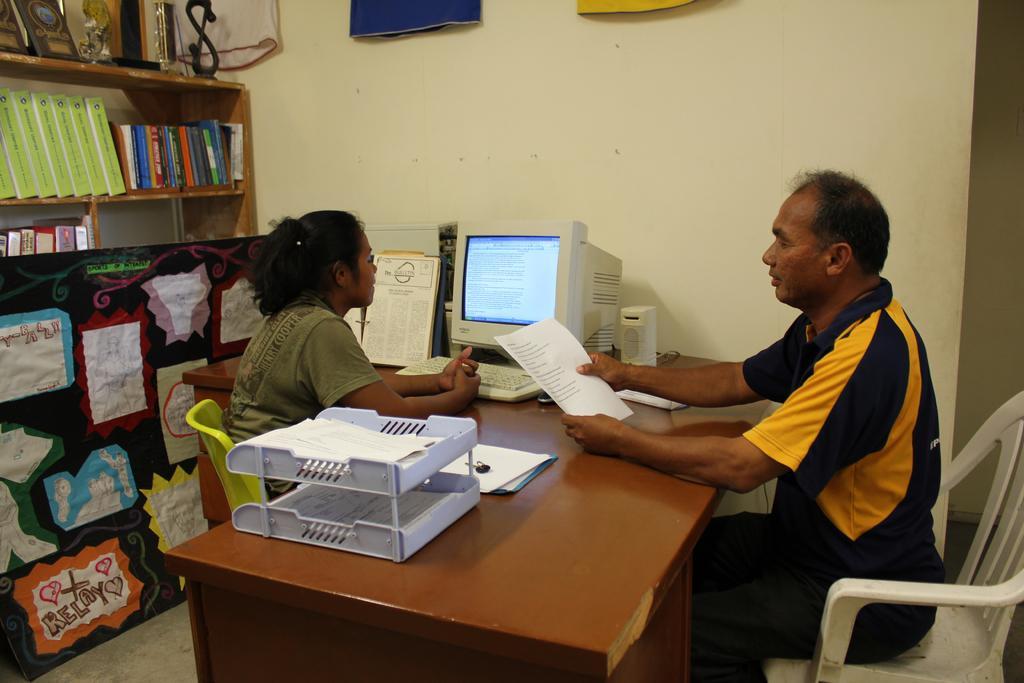Describe this image in one or two sentences. In this picture there is a man who is sitting in front of the lady and the lady is facing towards the system and she is operating the system, there are some papers and documents on the wooden desk and the shelf behind the lady contains books and noticed, there are trophies above the shelf. 